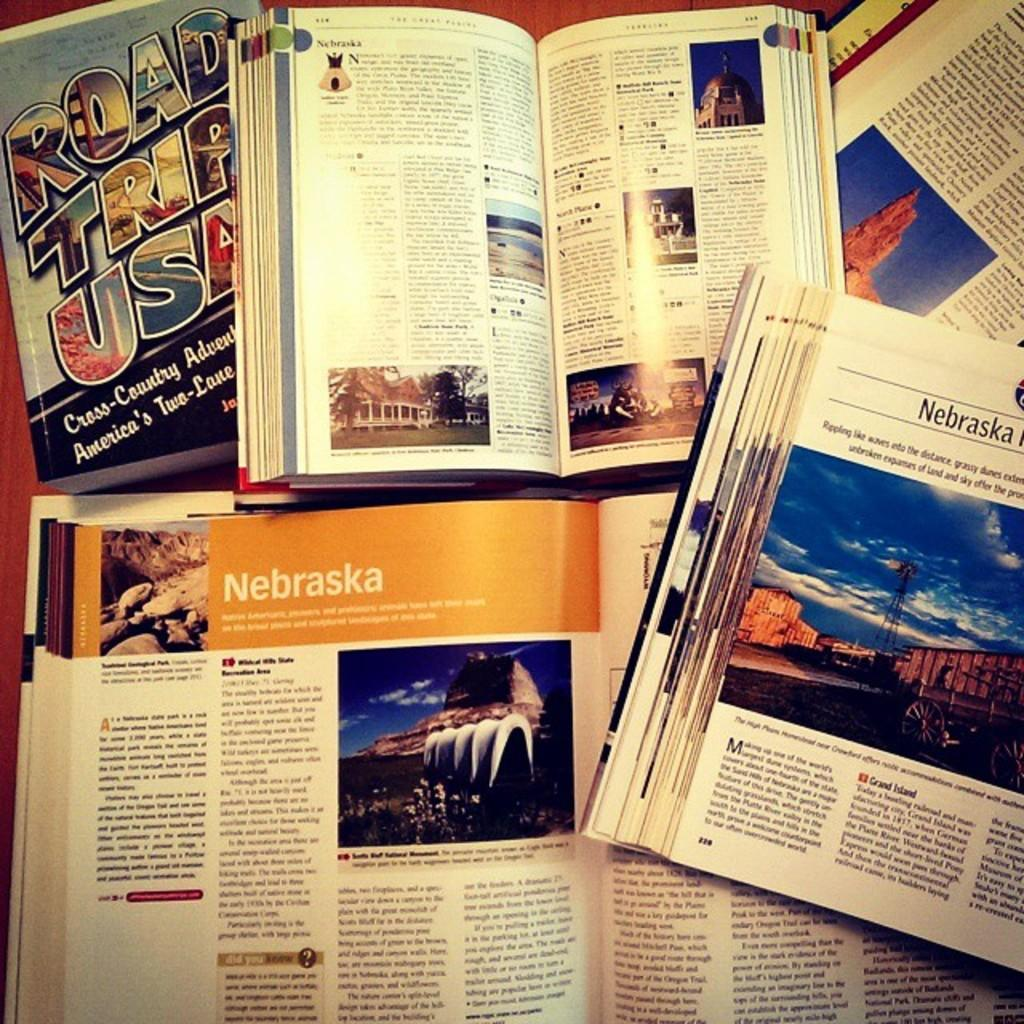<image>
Relay a brief, clear account of the picture shown. Several travel books are open to sections about Nebraska. 